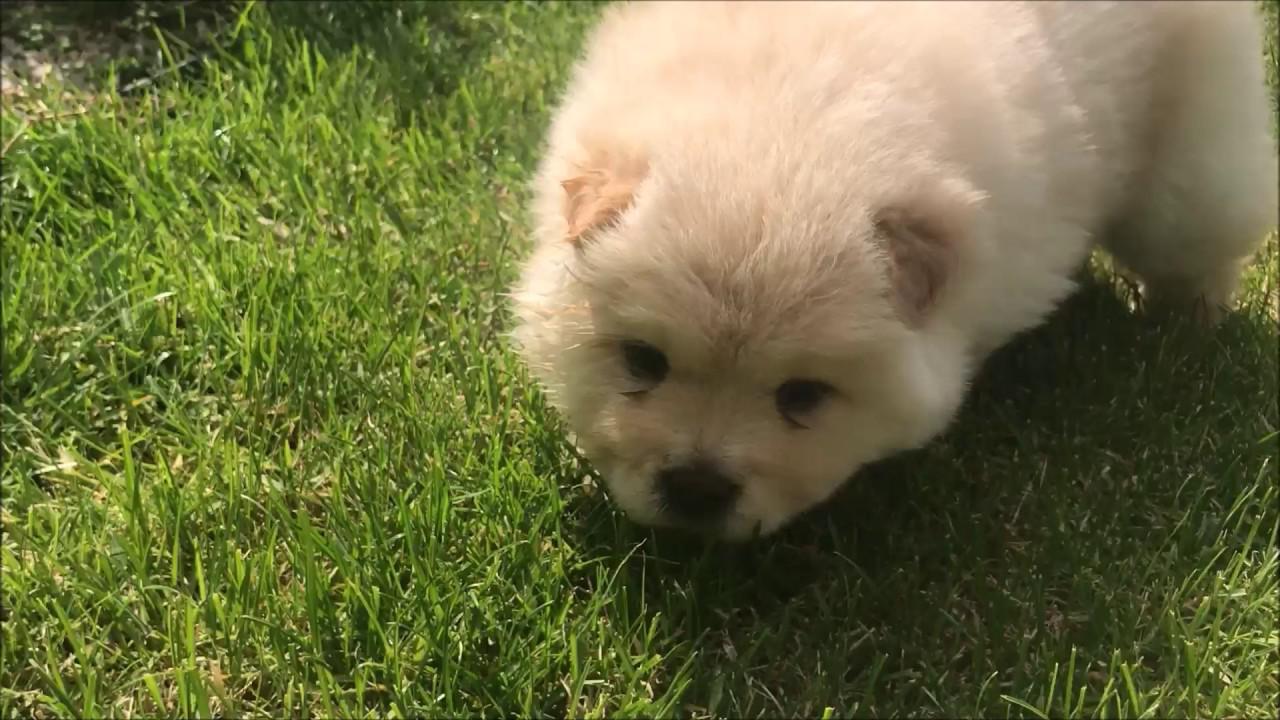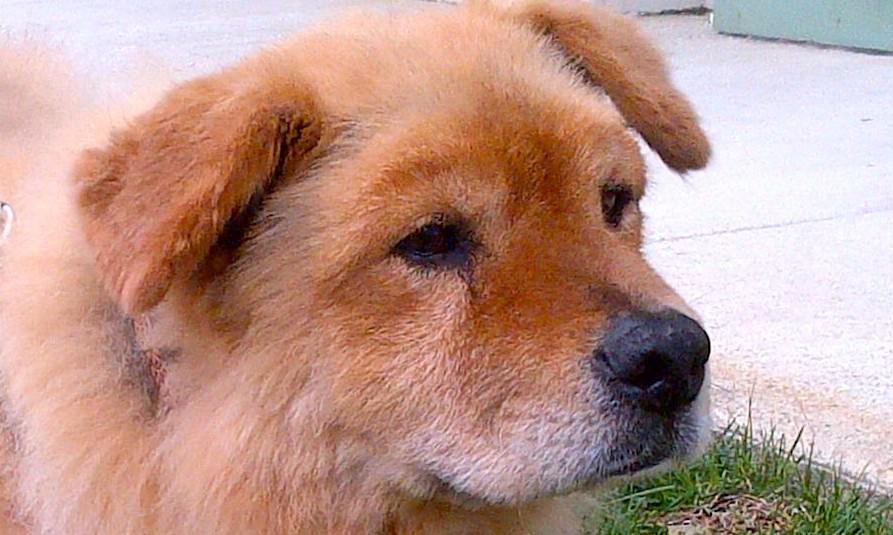The first image is the image on the left, the second image is the image on the right. Considering the images on both sides, is "Exactly two dogs can be seen to be standing, and have their white tails curled up and laying on their backs" valid? Answer yes or no. No. The first image is the image on the left, the second image is the image on the right. For the images shown, is this caption "The dog in the right image is looking towards the right." true? Answer yes or no. Yes. 